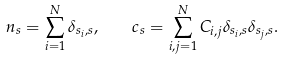<formula> <loc_0><loc_0><loc_500><loc_500>n _ { s } = \sum _ { i = 1 } ^ { N } \delta _ { s _ { i } , s } , \quad c _ { s } = \sum _ { i , j = 1 } ^ { N } C _ { i , j } \delta _ { s _ { i } , s } \delta _ { s _ { j } , s } .</formula> 